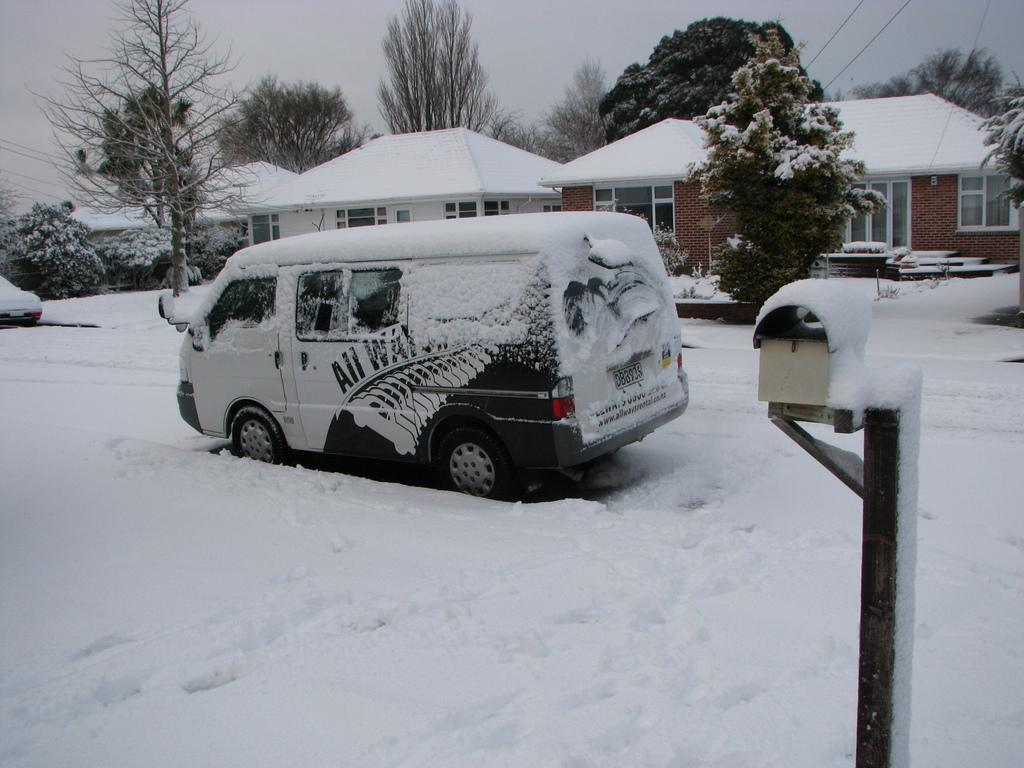What vehicle is present in the image? There is a van in the image. How is the van affected by the weather in the image? The van is covered with snow in the image. What type of terrain is visible at the bottom of the image? There is snow at the bottom of the image. What structures can be seen in the background of the image? There is a house and trees in the background of the image. What is visible at the top of the image? The sky is visible at the top of the image. What type of tray is being used to carry the snow off the van in the image? There is no tray present in the image, nor is anyone attempting to remove the snow from the van. 